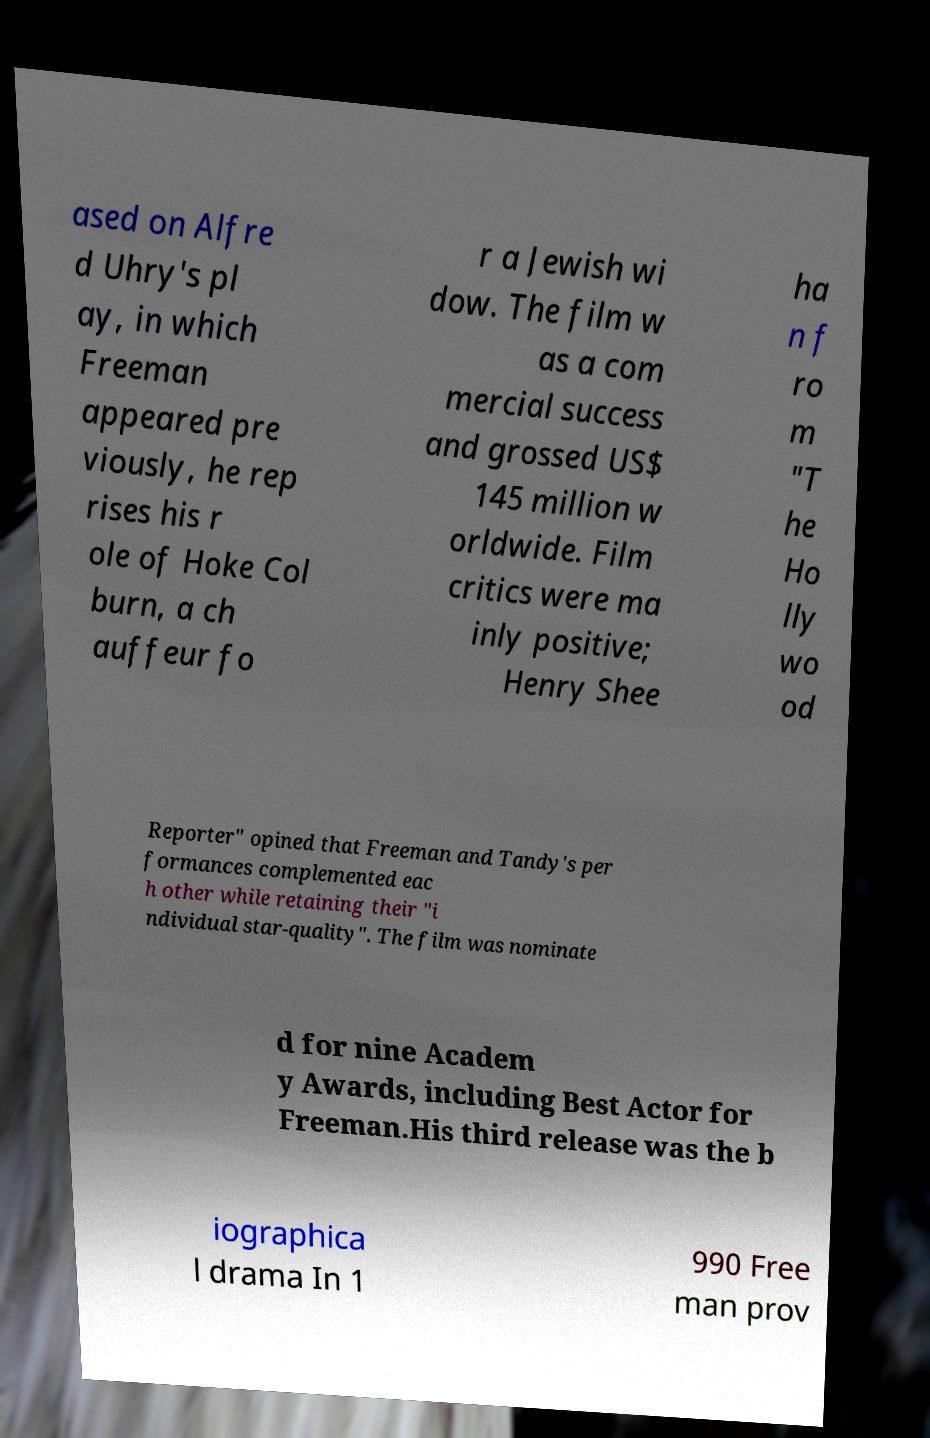For documentation purposes, I need the text within this image transcribed. Could you provide that? ased on Alfre d Uhry's pl ay, in which Freeman appeared pre viously, he rep rises his r ole of Hoke Col burn, a ch auffeur fo r a Jewish wi dow. The film w as a com mercial success and grossed US$ 145 million w orldwide. Film critics were ma inly positive; Henry Shee ha n f ro m "T he Ho lly wo od Reporter" opined that Freeman and Tandy's per formances complemented eac h other while retaining their "i ndividual star-quality". The film was nominate d for nine Academ y Awards, including Best Actor for Freeman.His third release was the b iographica l drama In 1 990 Free man prov 